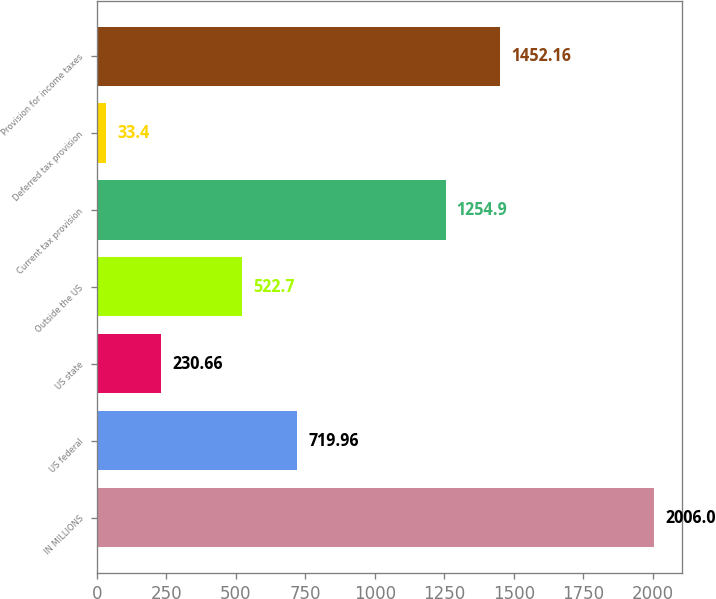Convert chart to OTSL. <chart><loc_0><loc_0><loc_500><loc_500><bar_chart><fcel>IN MILLIONS<fcel>US federal<fcel>US state<fcel>Outside the US<fcel>Current tax provision<fcel>Deferred tax provision<fcel>Provision for income taxes<nl><fcel>2006<fcel>719.96<fcel>230.66<fcel>522.7<fcel>1254.9<fcel>33.4<fcel>1452.16<nl></chart> 